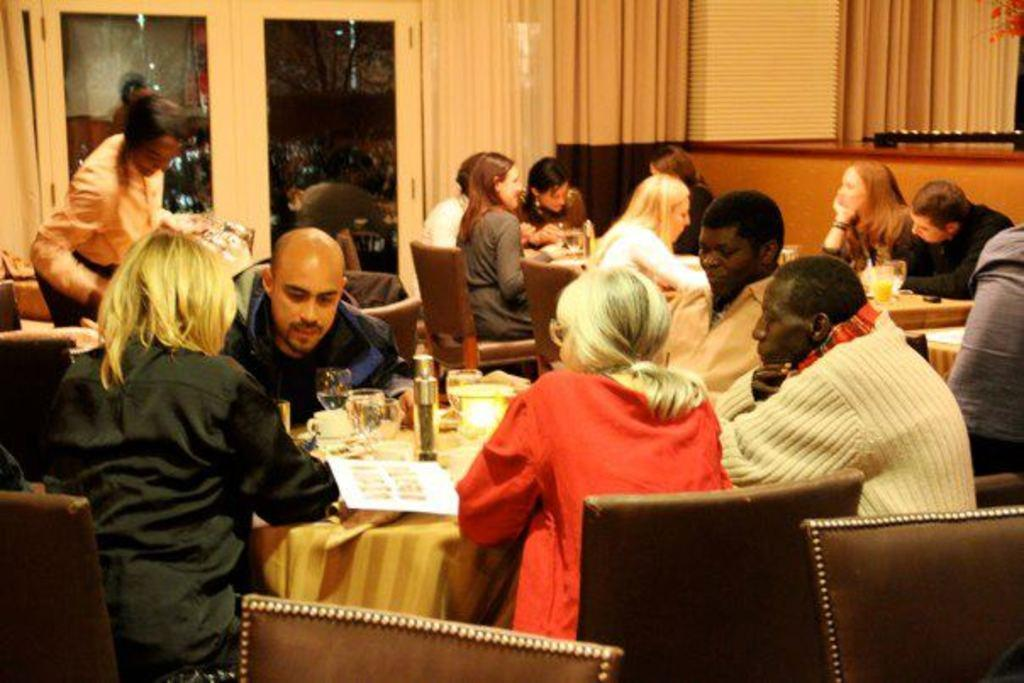What are the people in the image doing? The group of people are seated on chairs. What is present on the table in the image? There are glasses on the table. Is there any other furniture visible in the image? Yes, there is a table in the image. What is the position of the woman in the image? There is a woman standing in the image. Can you see a kitten playing in the field in the image? There is no kitten or field present in the image. What type of juice is being served in the glasses on the table? The image does not specify the type of juice in the glasses; it only shows that there are glasses on the table. 